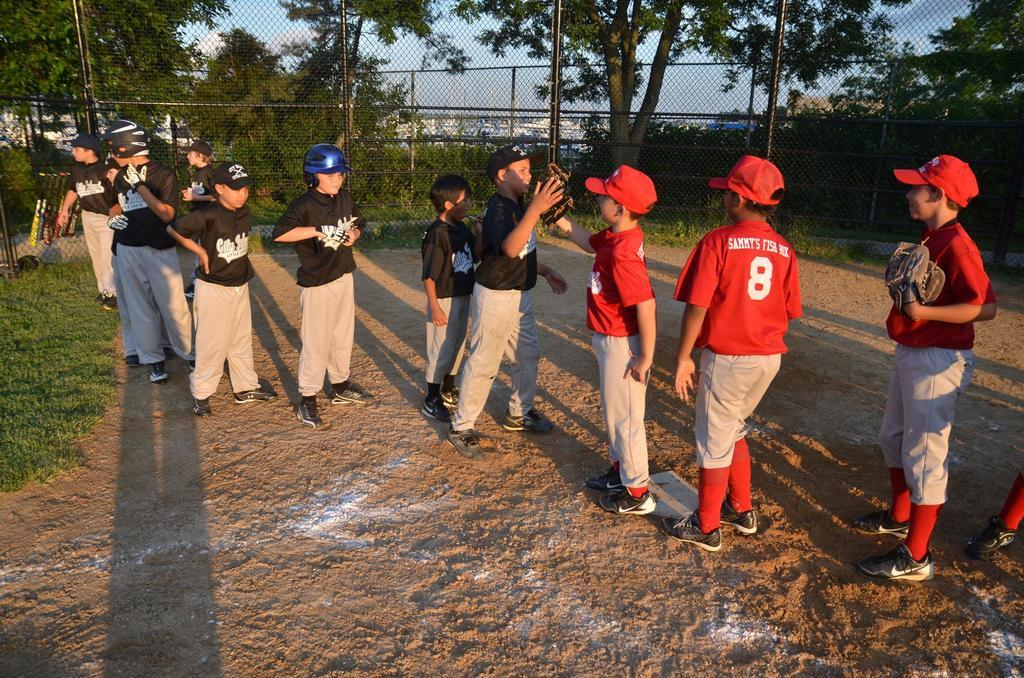<image>
Share a concise interpretation of the image provided. A kid with a number 8 jersey looks to give the other team high-fives. 